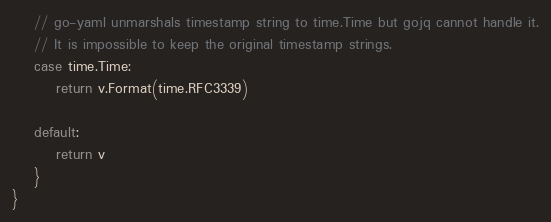Convert code to text. <code><loc_0><loc_0><loc_500><loc_500><_Go_>	// go-yaml unmarshals timestamp string to time.Time but gojq cannot handle it.
	// It is impossible to keep the original timestamp strings.
	case time.Time:
		return v.Format(time.RFC3339)

	default:
		return v
	}
}
</code> 